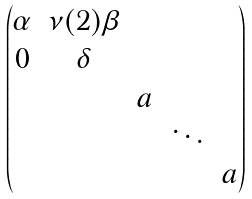<formula> <loc_0><loc_0><loc_500><loc_500>\begin{pmatrix} \alpha & \nu ( 2 ) \beta & & & \\ 0 & \delta & & & \\ & & a & & \\ & & & \ddots & \\ & & & & a \end{pmatrix}</formula> 